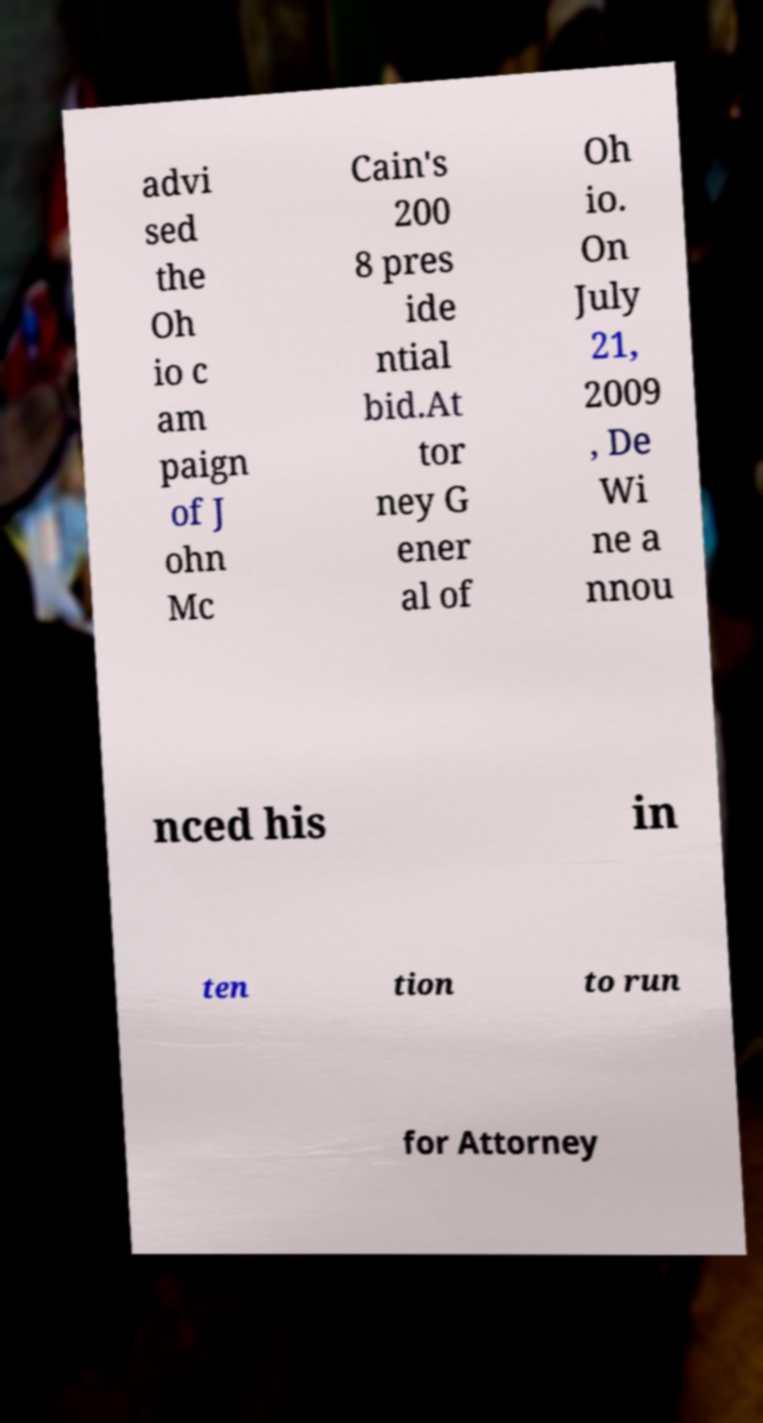Can you read and provide the text displayed in the image?This photo seems to have some interesting text. Can you extract and type it out for me? advi sed the Oh io c am paign of J ohn Mc Cain's 200 8 pres ide ntial bid.At tor ney G ener al of Oh io. On July 21, 2009 , De Wi ne a nnou nced his in ten tion to run for Attorney 